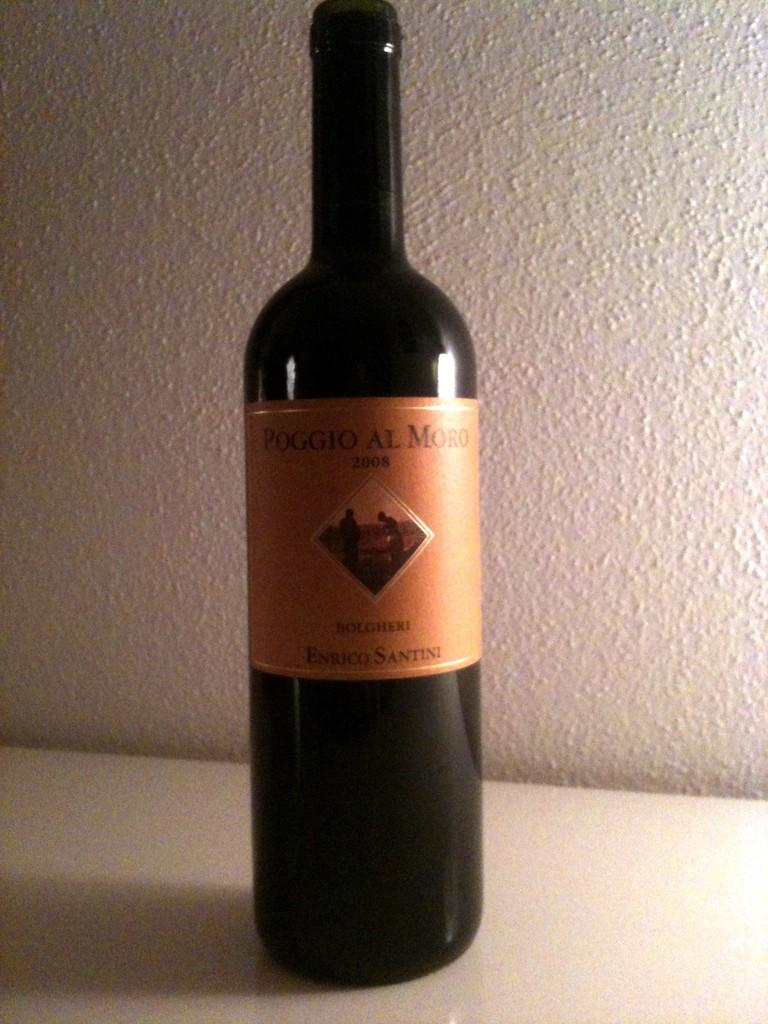<image>
Render a clear and concise summary of the photo. the word Poggio is on the wine bottle 